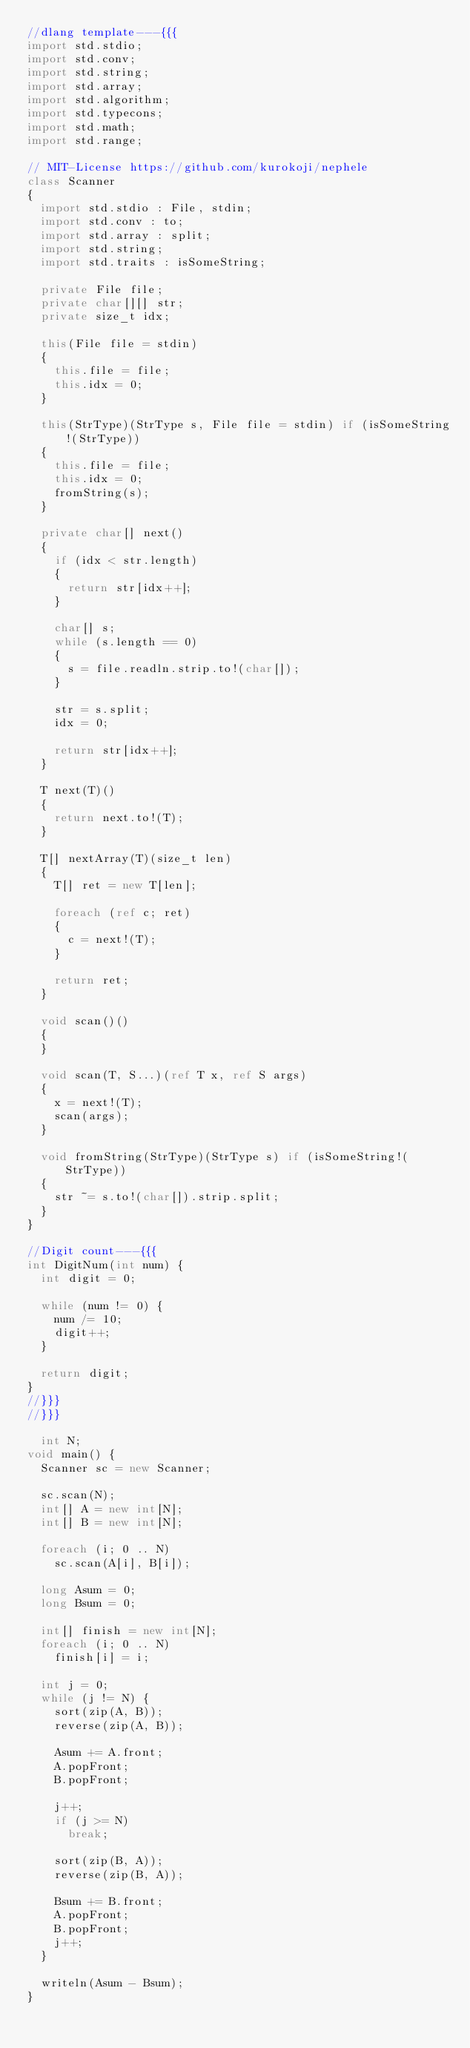<code> <loc_0><loc_0><loc_500><loc_500><_D_>//dlang template---{{{
import std.stdio;
import std.conv;
import std.string;
import std.array;
import std.algorithm;
import std.typecons;
import std.math;
import std.range;

// MIT-License https://github.com/kurokoji/nephele
class Scanner
{
  import std.stdio : File, stdin;
  import std.conv : to;
  import std.array : split;
  import std.string;
  import std.traits : isSomeString;

  private File file;
  private char[][] str;
  private size_t idx;

  this(File file = stdin)
  {
    this.file = file;
    this.idx = 0;
  }

  this(StrType)(StrType s, File file = stdin) if (isSomeString!(StrType))
  {
    this.file = file;
    this.idx = 0;
    fromString(s);
  }

  private char[] next()
  {
    if (idx < str.length)
    {
      return str[idx++];
    }

    char[] s;
    while (s.length == 0)
    {
      s = file.readln.strip.to!(char[]);
    }

    str = s.split;
    idx = 0;

    return str[idx++];
  }

  T next(T)()
  {
    return next.to!(T);
  }

  T[] nextArray(T)(size_t len)
  {
    T[] ret = new T[len];

    foreach (ref c; ret)
    {
      c = next!(T);
    }

    return ret;
  }

  void scan()()
  {
  }

  void scan(T, S...)(ref T x, ref S args)
  {
    x = next!(T);
    scan(args);
  }

  void fromString(StrType)(StrType s) if (isSomeString!(StrType))
  {
    str ~= s.to!(char[]).strip.split;
  }
}

//Digit count---{{{
int DigitNum(int num) {
  int digit = 0;

  while (num != 0) {
    num /= 10;
    digit++;
  }

  return digit;
}
//}}}
//}}}

  int N;
void main() {
  Scanner sc = new Scanner;

  sc.scan(N);
  int[] A = new int[N];
  int[] B = new int[N];

  foreach (i; 0 .. N)
    sc.scan(A[i], B[i]);

  long Asum = 0;
  long Bsum = 0;

  int[] finish = new int[N];
  foreach (i; 0 .. N)
    finish[i] = i;

  int j = 0;
  while (j != N) {
    sort(zip(A, B));
    reverse(zip(A, B));

    Asum += A.front;
    A.popFront;
    B.popFront;

    j++;
    if (j >= N)
      break;

    sort(zip(B, A));
    reverse(zip(B, A));

    Bsum += B.front;
    A.popFront;
    B.popFront;
    j++;
  }

  writeln(Asum - Bsum);
}
</code> 